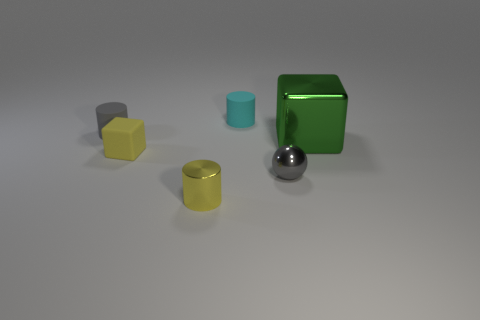What size is the green shiny object that is the same shape as the small yellow matte thing?
Make the answer very short. Large. What number of gray things are both behind the large block and in front of the small cube?
Keep it short and to the point. 0. Does the yellow rubber thing have the same shape as the metal object behind the small yellow cube?
Your answer should be compact. Yes. Is the number of balls that are on the left side of the cyan matte object greater than the number of big green cubes?
Make the answer very short. No. Are there fewer things that are in front of the tiny yellow shiny cylinder than big purple metallic blocks?
Your response must be concise. No. How many other big metallic cubes are the same color as the metal cube?
Offer a terse response. 0. There is a small thing that is to the left of the yellow shiny cylinder and in front of the gray rubber thing; what is it made of?
Your answer should be very brief. Rubber. Does the small matte thing right of the tiny yellow rubber object have the same color as the matte object that is to the left of the rubber block?
Offer a very short reply. No. How many purple things are big metal things or tiny rubber objects?
Ensure brevity in your answer.  0. Is the number of tiny yellow matte things that are in front of the small gray rubber cylinder less than the number of cyan matte objects that are to the right of the big metallic object?
Provide a short and direct response. No. 